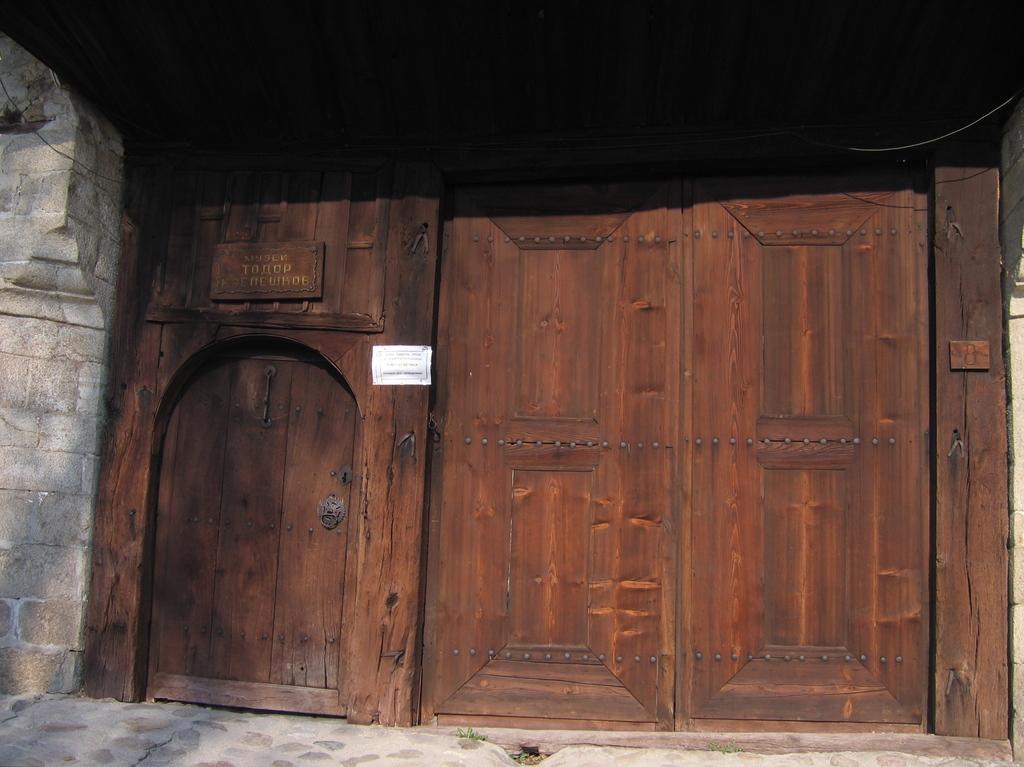In one or two sentences, can you explain what this image depicts? In this image there is a door and on the door there is a board and there is a paper with some text written on it. On the left side there is a wall. 